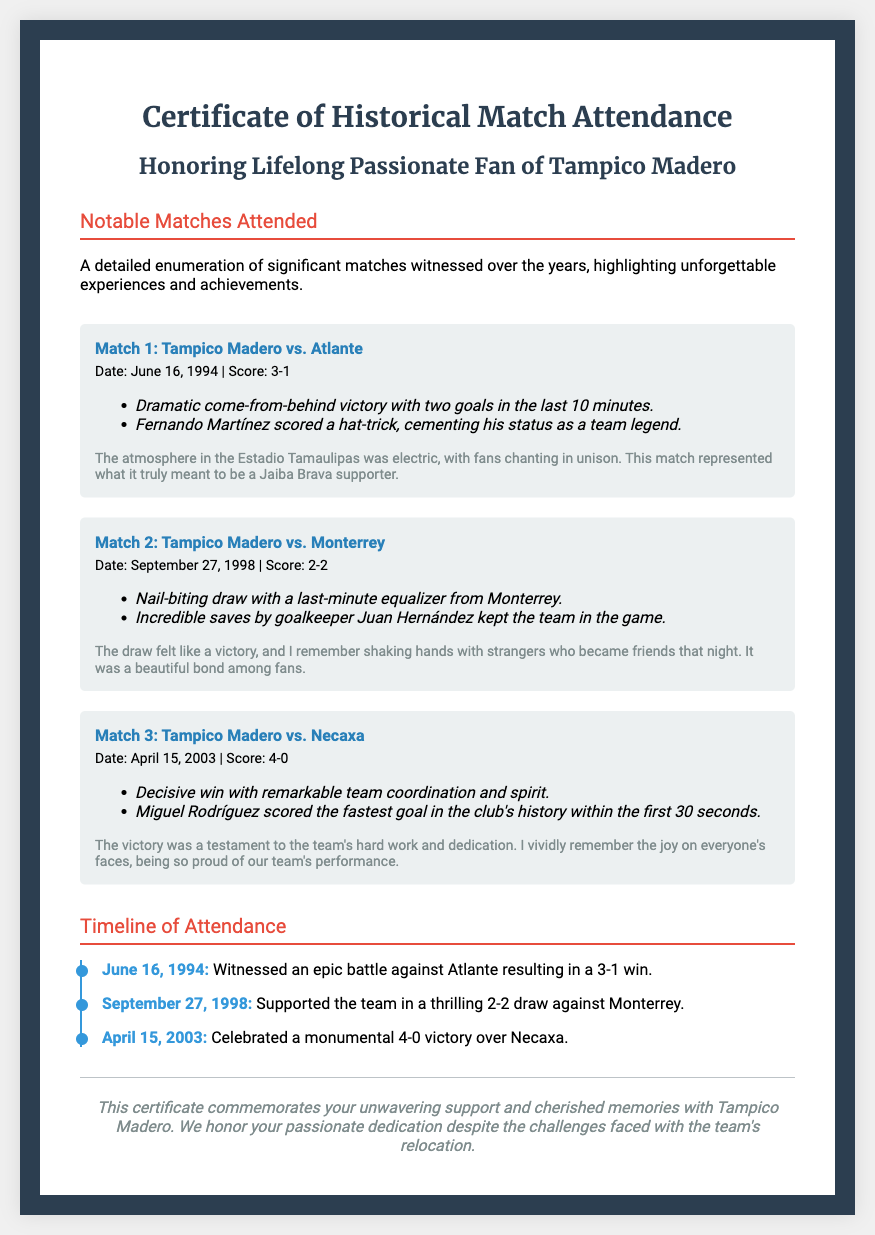What is the title of the document? The title is prominently displayed at the top of the certificate.
Answer: Certificate of Historical Match Attendance Who did Tampico Madero play against on June 16, 1994? The match details specifically state the opposing team in the match section.
Answer: Atlante What was the score of the match on April 15, 2003? The score is provided in the match details format for the specific date.
Answer: 4-0 Which player scored a hat-trick in the match against Atlante? The document mentions the player's achievement in the highlights of that match.
Answer: Fernando Martínez What significant event occurred during the match against Monterrey? The highlights section describes this notable moment in the game.
Answer: Last-minute equalizer What percentage of matches listed resulted in a victory for Tampico Madero? Analyzing the outcomes of the three matches, two were wins, and one was a draw.
Answer: 66.67% When did the match against Necaxa take place? The date of this memorable match is clearly provided in the match details.
Answer: April 15, 2003 What is the purpose of this certificate? The document specifies its purpose in the footer section.
Answer: Commemorates unwavering support How many noteworthy matches are documented? The number can be counted from the document's notable matches section.
Answer: Three 